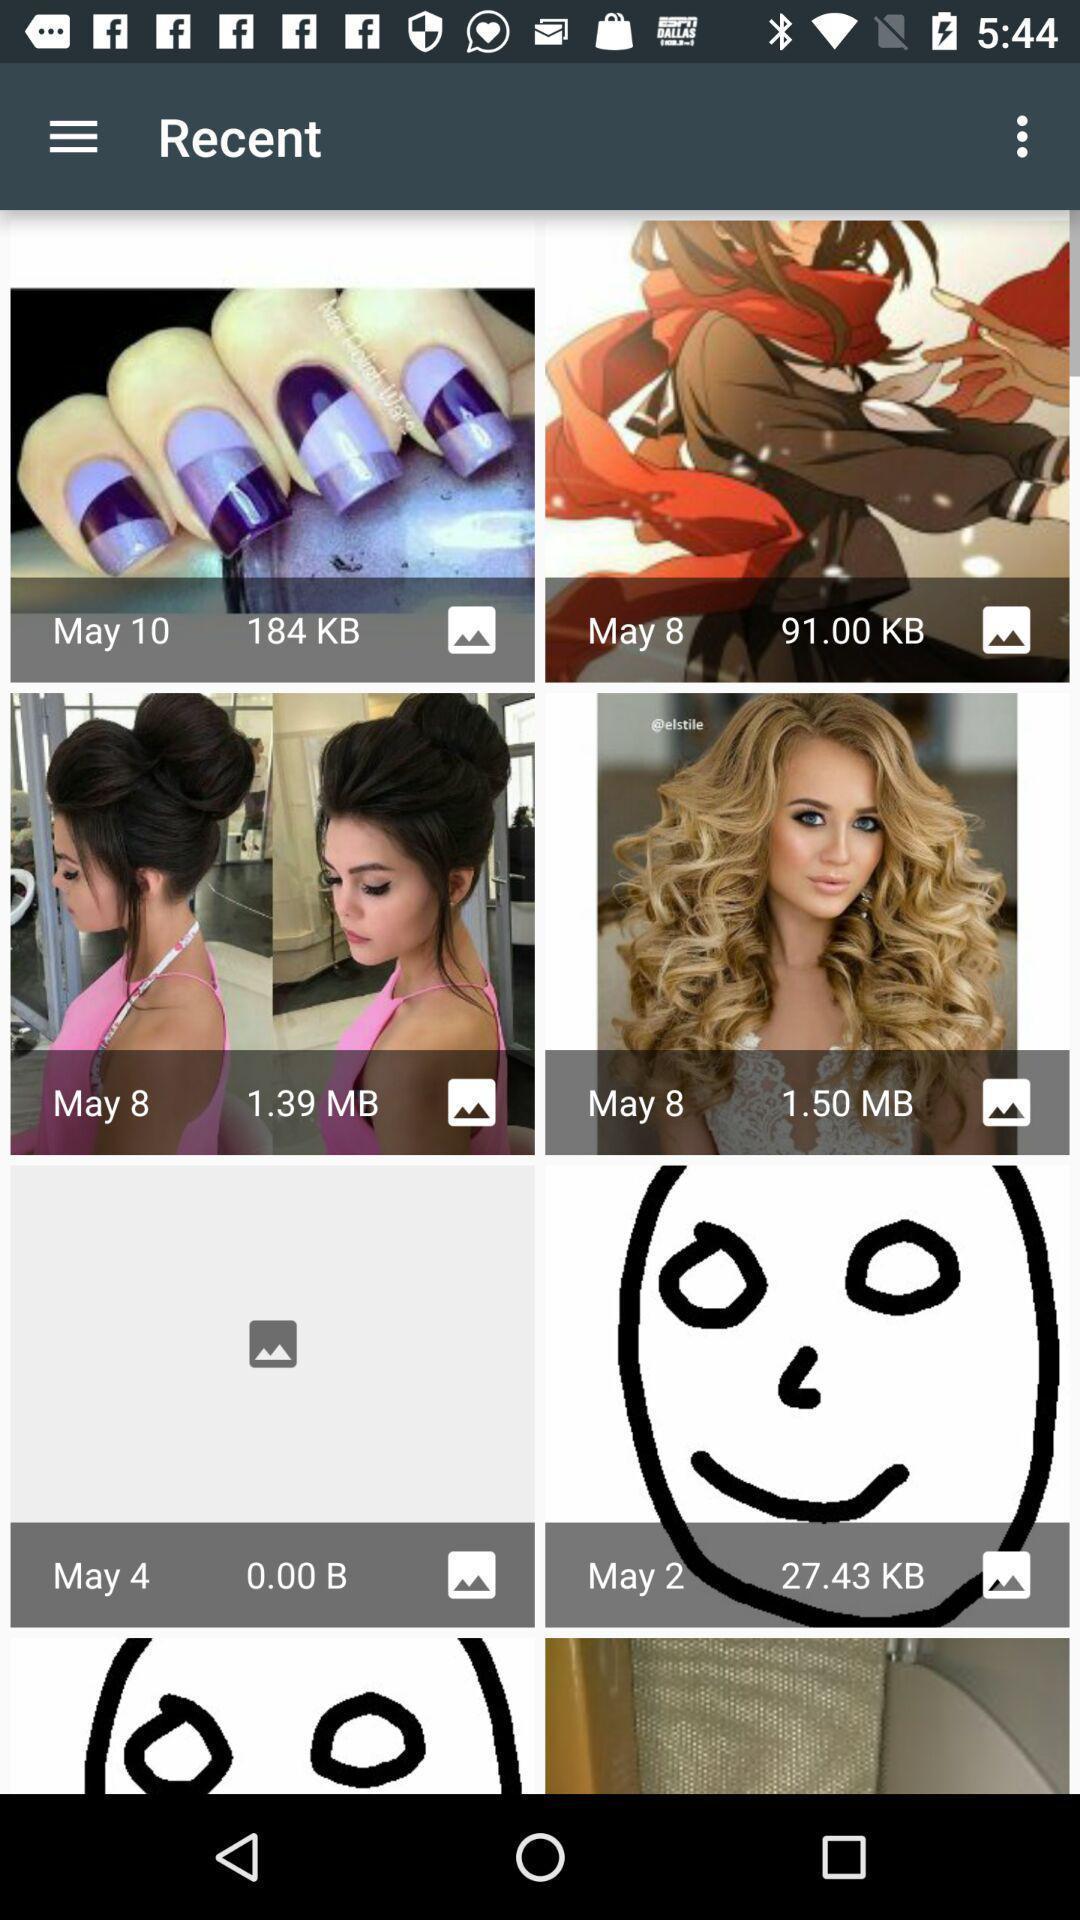Tell me what you see in this picture. Screen showing images. 